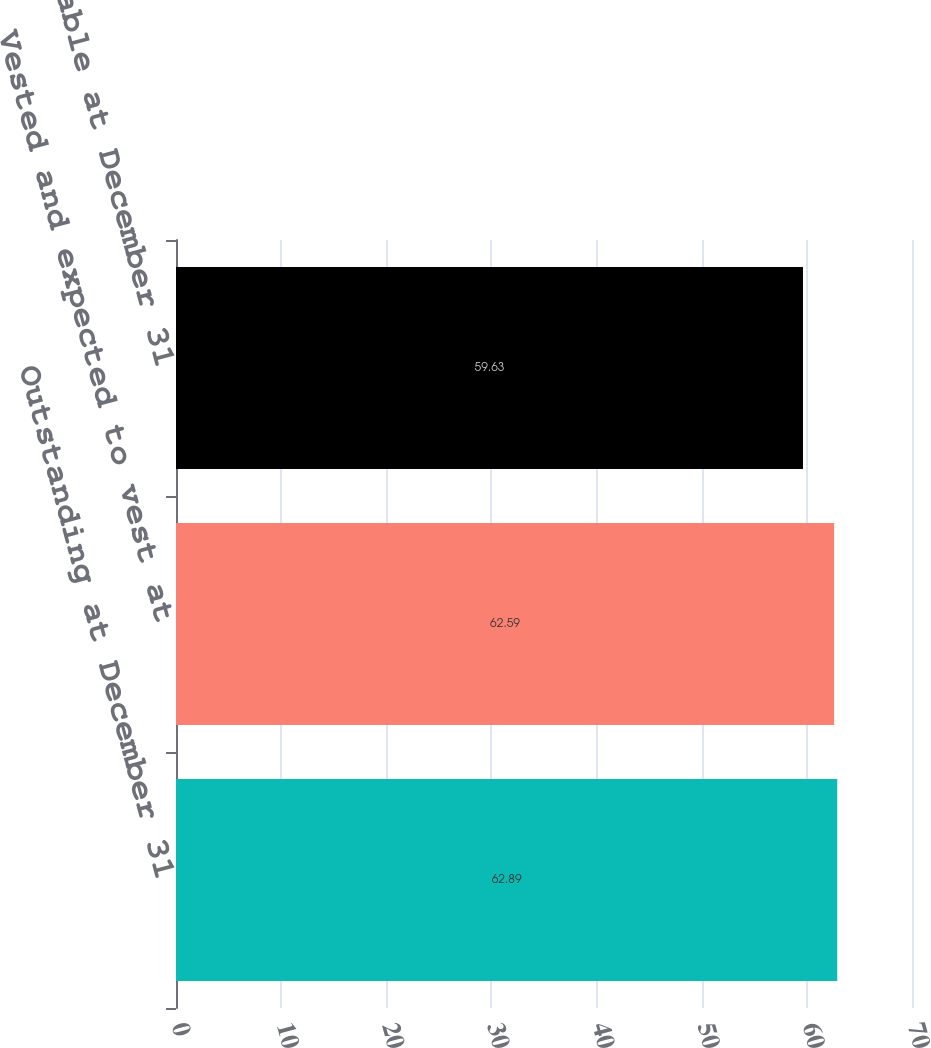<chart> <loc_0><loc_0><loc_500><loc_500><bar_chart><fcel>Outstanding at December 31<fcel>Vested and expected to vest at<fcel>Exercisable at December 31<nl><fcel>62.89<fcel>62.59<fcel>59.63<nl></chart> 